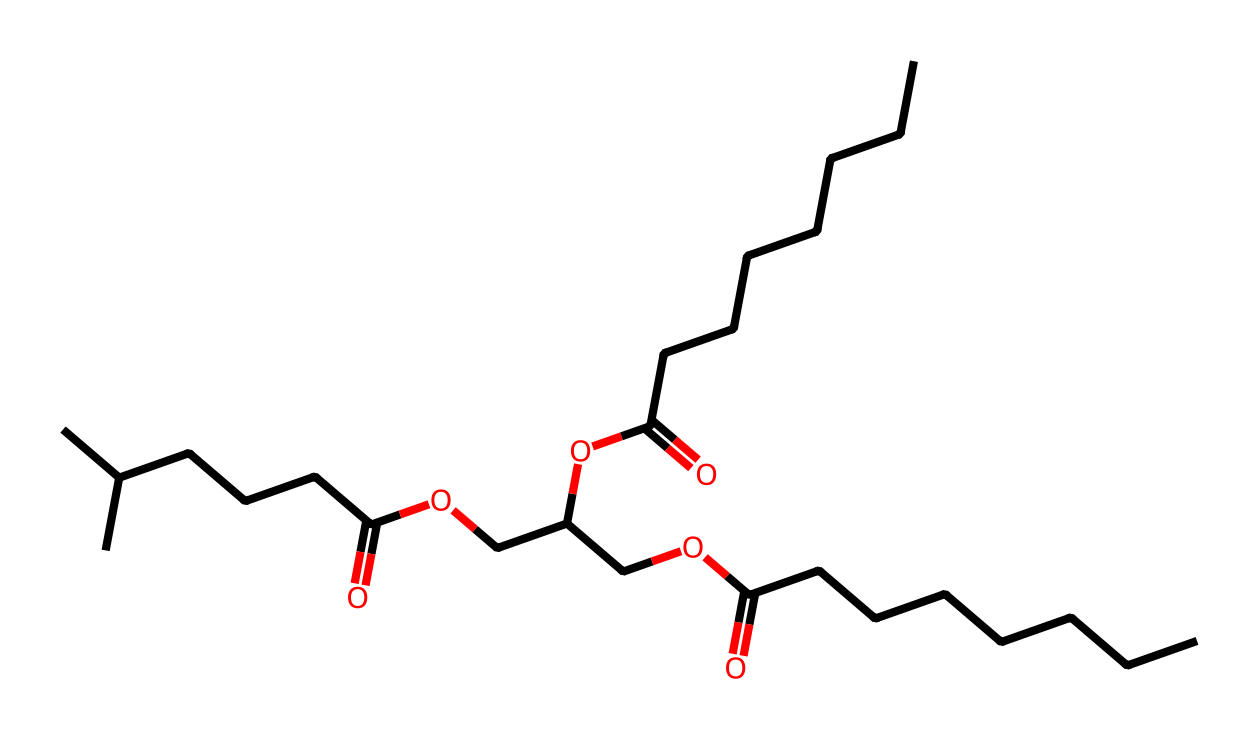What type of functional groups are present in this chemical? The SMILES representation indicates the presence of carboxylic acid groups (as seen in the –COOH structure) and ester groups (indicated by the -O- connections between carbon chains and carbonyls).
Answer: carboxylic acid, ester How many carbon atoms are in this molecule? By analyzing the structure represented in the SMILES, we can count the number of 'C' characters, which represents carbon atoms; there are 21 carbon atoms in total.
Answer: 21 What is the molecular weight of this compound approximately? The molecular weight can be estimated by summing the atomic weights of all the atoms present (C, H, O); the approximate molecular weight calculated for 21 carbons, 40 hydrogens, and 5 oxygens is around 350 g/mol.
Answer: 350 g/mol Which component contributes to the lubricating properties of this chemical? The long hydrocarbon chains (alkyl chains) present in the structure provide the necessary thickness and viscosity for lubrication, enhancing the hydrophobic nature and reducing friction.
Answer: alkyl chains Is this compound biodegradable? Given that this chemical is derived from agricultural waste and contains ester and carboxylic acid functional groups, it is likely to be biodegradable, as these structures are susceptible to breakdown by microorganisms.
Answer: biodegradable 